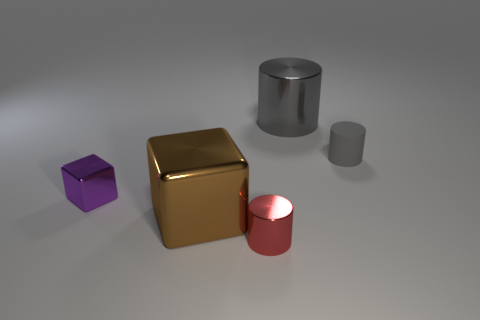Add 1 large brown metallic cubes. How many objects exist? 6 Subtract all cylinders. How many objects are left? 2 Subtract 0 purple cylinders. How many objects are left? 5 Subtract all gray rubber things. Subtract all large purple cubes. How many objects are left? 4 Add 2 big metallic cylinders. How many big metallic cylinders are left? 3 Add 3 large blue metallic cubes. How many large blue metallic cubes exist? 3 